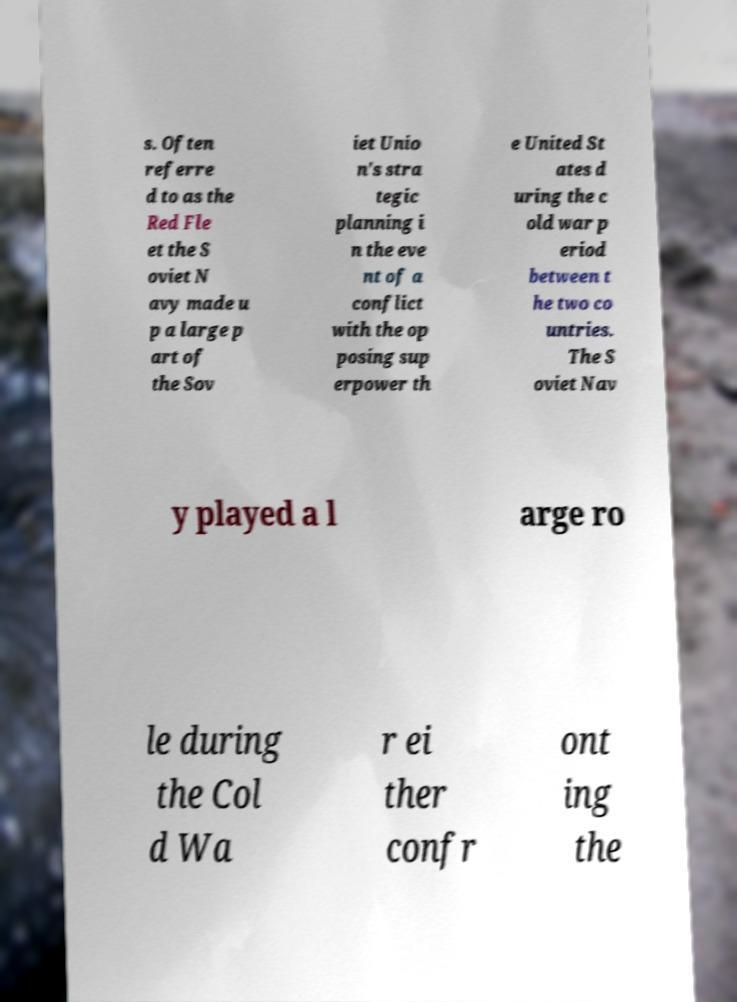Could you assist in decoding the text presented in this image and type it out clearly? s. Often referre d to as the Red Fle et the S oviet N avy made u p a large p art of the Sov iet Unio n's stra tegic planning i n the eve nt of a conflict with the op posing sup erpower th e United St ates d uring the c old war p eriod between t he two co untries. The S oviet Nav y played a l arge ro le during the Col d Wa r ei ther confr ont ing the 